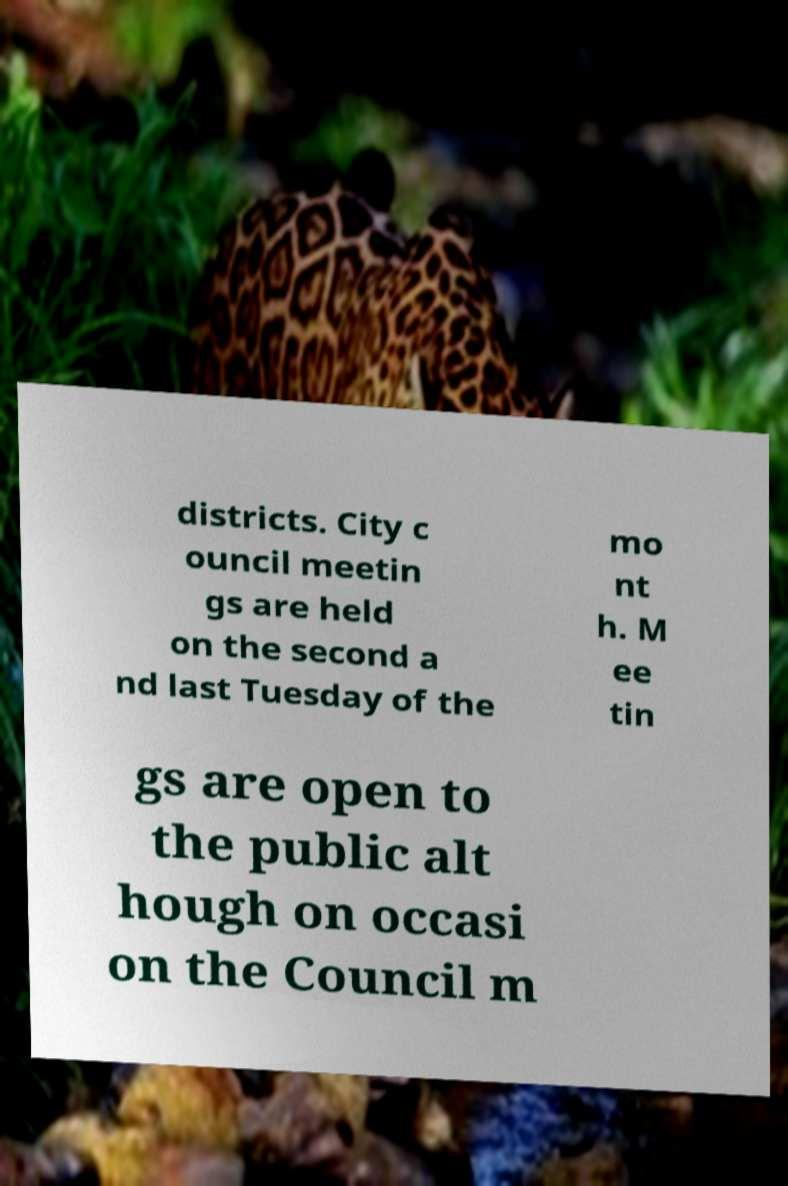What messages or text are displayed in this image? I need them in a readable, typed format. districts. City c ouncil meetin gs are held on the second a nd last Tuesday of the mo nt h. M ee tin gs are open to the public alt hough on occasi on the Council m 